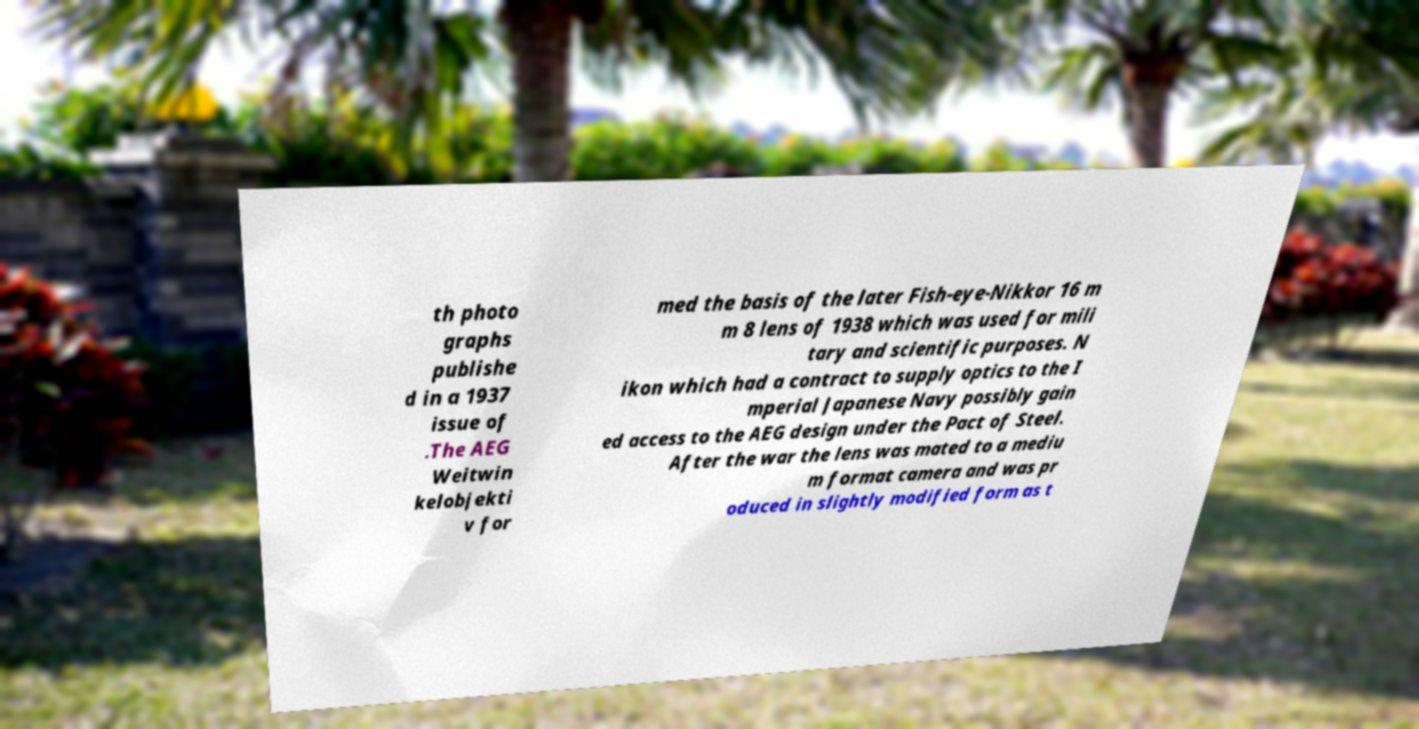I need the written content from this picture converted into text. Can you do that? th photo graphs publishe d in a 1937 issue of .The AEG Weitwin kelobjekti v for med the basis of the later Fish-eye-Nikkor 16 m m 8 lens of 1938 which was used for mili tary and scientific purposes. N ikon which had a contract to supply optics to the I mperial Japanese Navy possibly gain ed access to the AEG design under the Pact of Steel. After the war the lens was mated to a mediu m format camera and was pr oduced in slightly modified form as t 